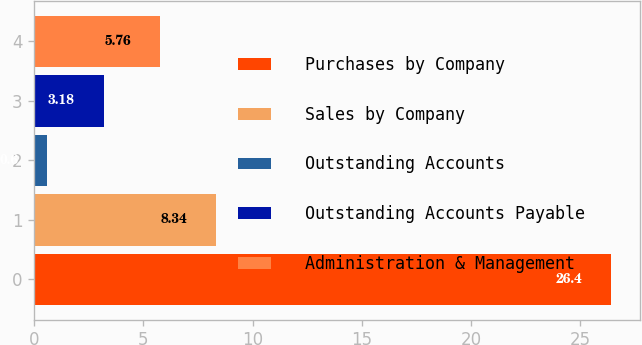Convert chart to OTSL. <chart><loc_0><loc_0><loc_500><loc_500><bar_chart><fcel>Purchases by Company<fcel>Sales by Company<fcel>Outstanding Accounts<fcel>Outstanding Accounts Payable<fcel>Administration & Management<nl><fcel>26.4<fcel>8.34<fcel>0.6<fcel>3.18<fcel>5.76<nl></chart> 